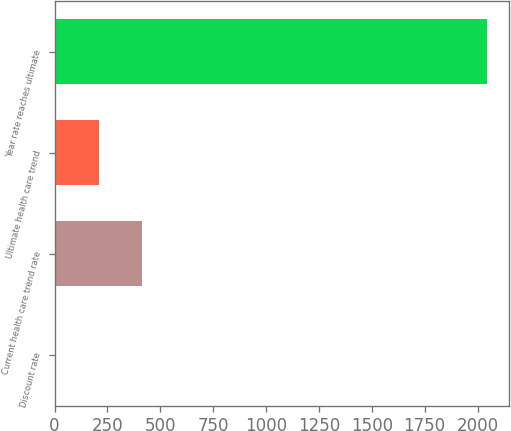Convert chart. <chart><loc_0><loc_0><loc_500><loc_500><bar_chart><fcel>Discount rate<fcel>Current health care trend rate<fcel>Ultimate health care trend<fcel>Year rate reaches ultimate<nl><fcel>4.25<fcel>412.41<fcel>208.33<fcel>2045<nl></chart> 